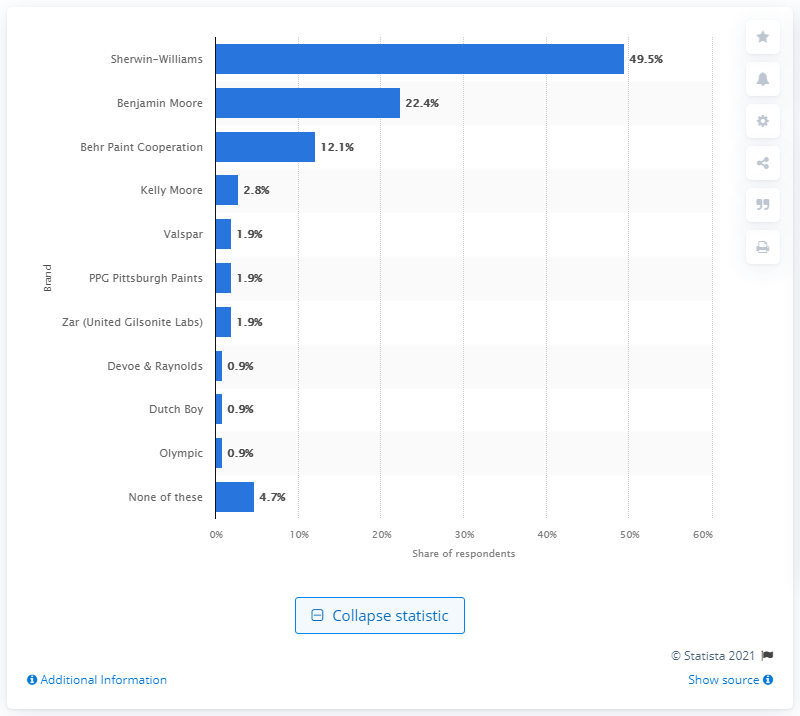Point out several critical features in this image. According to a recent survey, Sherwin-Williams was the most commonly used brand of paint by U.S. construction firms in 2018. 